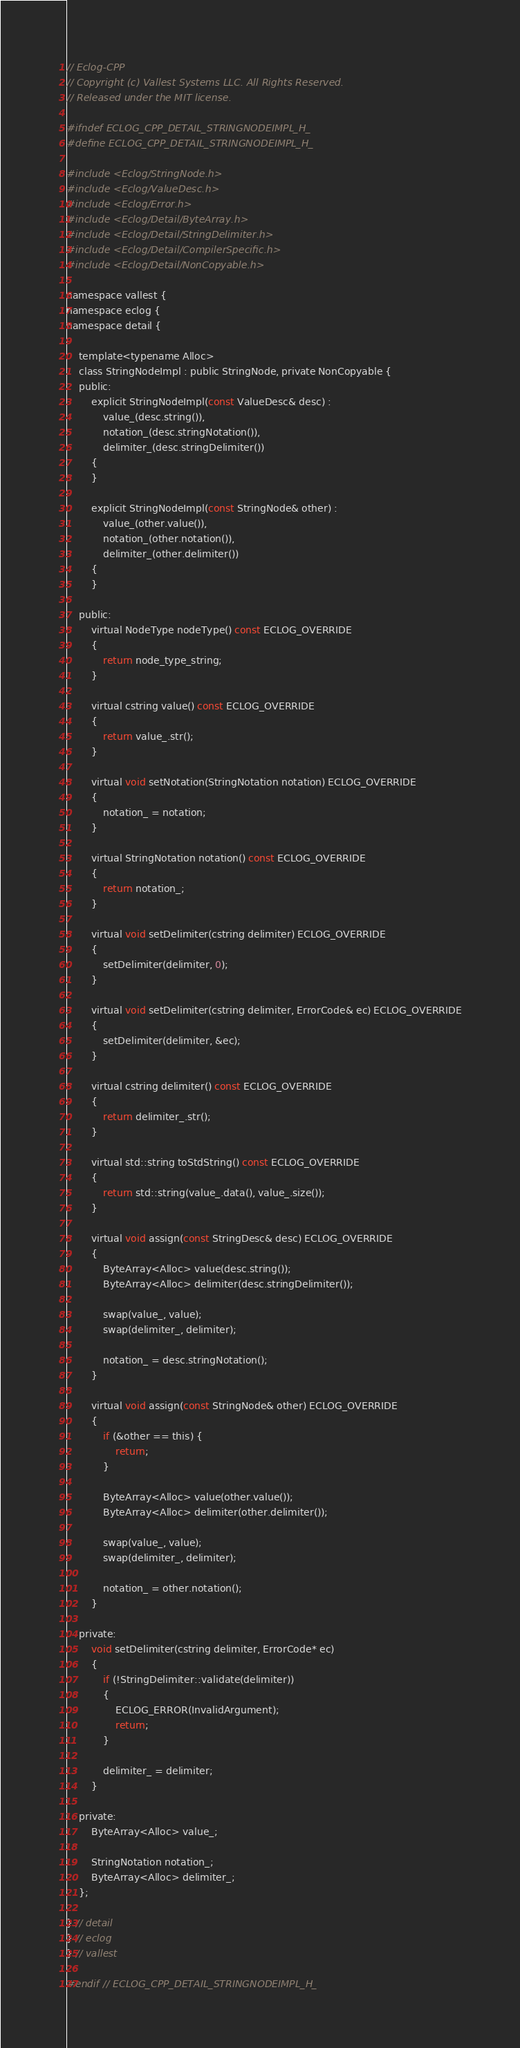<code> <loc_0><loc_0><loc_500><loc_500><_C_>// Eclog-CPP
// Copyright (c) Vallest Systems LLC. All Rights Reserved.
// Released under the MIT license.

#ifndef ECLOG_CPP_DETAIL_STRINGNODEIMPL_H_
#define ECLOG_CPP_DETAIL_STRINGNODEIMPL_H_

#include <Eclog/StringNode.h>
#include <Eclog/ValueDesc.h>
#include <Eclog/Error.h>
#include <Eclog/Detail/ByteArray.h>
#include <Eclog/Detail/StringDelimiter.h>
#include <Eclog/Detail/CompilerSpecific.h>
#include <Eclog/Detail/NonCopyable.h>

namespace vallest {
namespace eclog {
namespace detail {

	template<typename Alloc>
	class StringNodeImpl : public StringNode, private NonCopyable {
	public:
		explicit StringNodeImpl(const ValueDesc& desc) :
			value_(desc.string()),
			notation_(desc.stringNotation()),
			delimiter_(desc.stringDelimiter())
		{
		}

		explicit StringNodeImpl(const StringNode& other) :
			value_(other.value()),
			notation_(other.notation()),
			delimiter_(other.delimiter())
		{
		}

	public:
		virtual NodeType nodeType() const ECLOG_OVERRIDE
		{
			return node_type_string;
		}

		virtual cstring value() const ECLOG_OVERRIDE
		{
			return value_.str();
		}

		virtual void setNotation(StringNotation notation) ECLOG_OVERRIDE
		{
			notation_ = notation;
		}

		virtual StringNotation notation() const ECLOG_OVERRIDE
		{
			return notation_;
		}

		virtual void setDelimiter(cstring delimiter) ECLOG_OVERRIDE
		{
			setDelimiter(delimiter, 0);
		}

		virtual void setDelimiter(cstring delimiter, ErrorCode& ec) ECLOG_OVERRIDE
		{
			setDelimiter(delimiter, &ec);
		}

		virtual cstring delimiter() const ECLOG_OVERRIDE
		{
			return delimiter_.str();
		}

		virtual std::string toStdString() const ECLOG_OVERRIDE
		{
			return std::string(value_.data(), value_.size());
		}

		virtual void assign(const StringDesc& desc) ECLOG_OVERRIDE
		{
			ByteArray<Alloc> value(desc.string());
			ByteArray<Alloc> delimiter(desc.stringDelimiter());

			swap(value_, value);
			swap(delimiter_, delimiter);

			notation_ = desc.stringNotation();
		}

		virtual void assign(const StringNode& other) ECLOG_OVERRIDE
		{
			if (&other == this) {
				return;
			}

			ByteArray<Alloc> value(other.value());
			ByteArray<Alloc> delimiter(other.delimiter());

			swap(value_, value);
			swap(delimiter_, delimiter);

			notation_ = other.notation();
		}

	private:
		void setDelimiter(cstring delimiter, ErrorCode* ec)
		{
			if (!StringDelimiter::validate(delimiter))
			{
				ECLOG_ERROR(InvalidArgument);
				return;
			}

			delimiter_ = delimiter;
		}

	private:
		ByteArray<Alloc> value_;

		StringNotation notation_;
		ByteArray<Alloc> delimiter_;
	};

} // detail
} // eclog
} // vallest

#endif // ECLOG_CPP_DETAIL_STRINGNODEIMPL_H_

</code> 